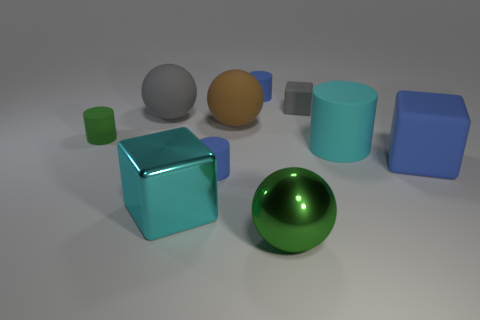What could be the possible materials of these objects? While we can't be certain without direct interaction, we can speculate based on their appearance. The objects seem to have different textures: the large blue cube appears to have a matte finish, suggesting it could be made of a material like painted wood or plastic. The cyan blue cube and the green geometric shapes have a slightly reflective surface that could indicate a smooth plastic or polished stone. The grey sphere and the brown cuboid have a duller surface, hinting at a matte clay or a similarly textured material. 